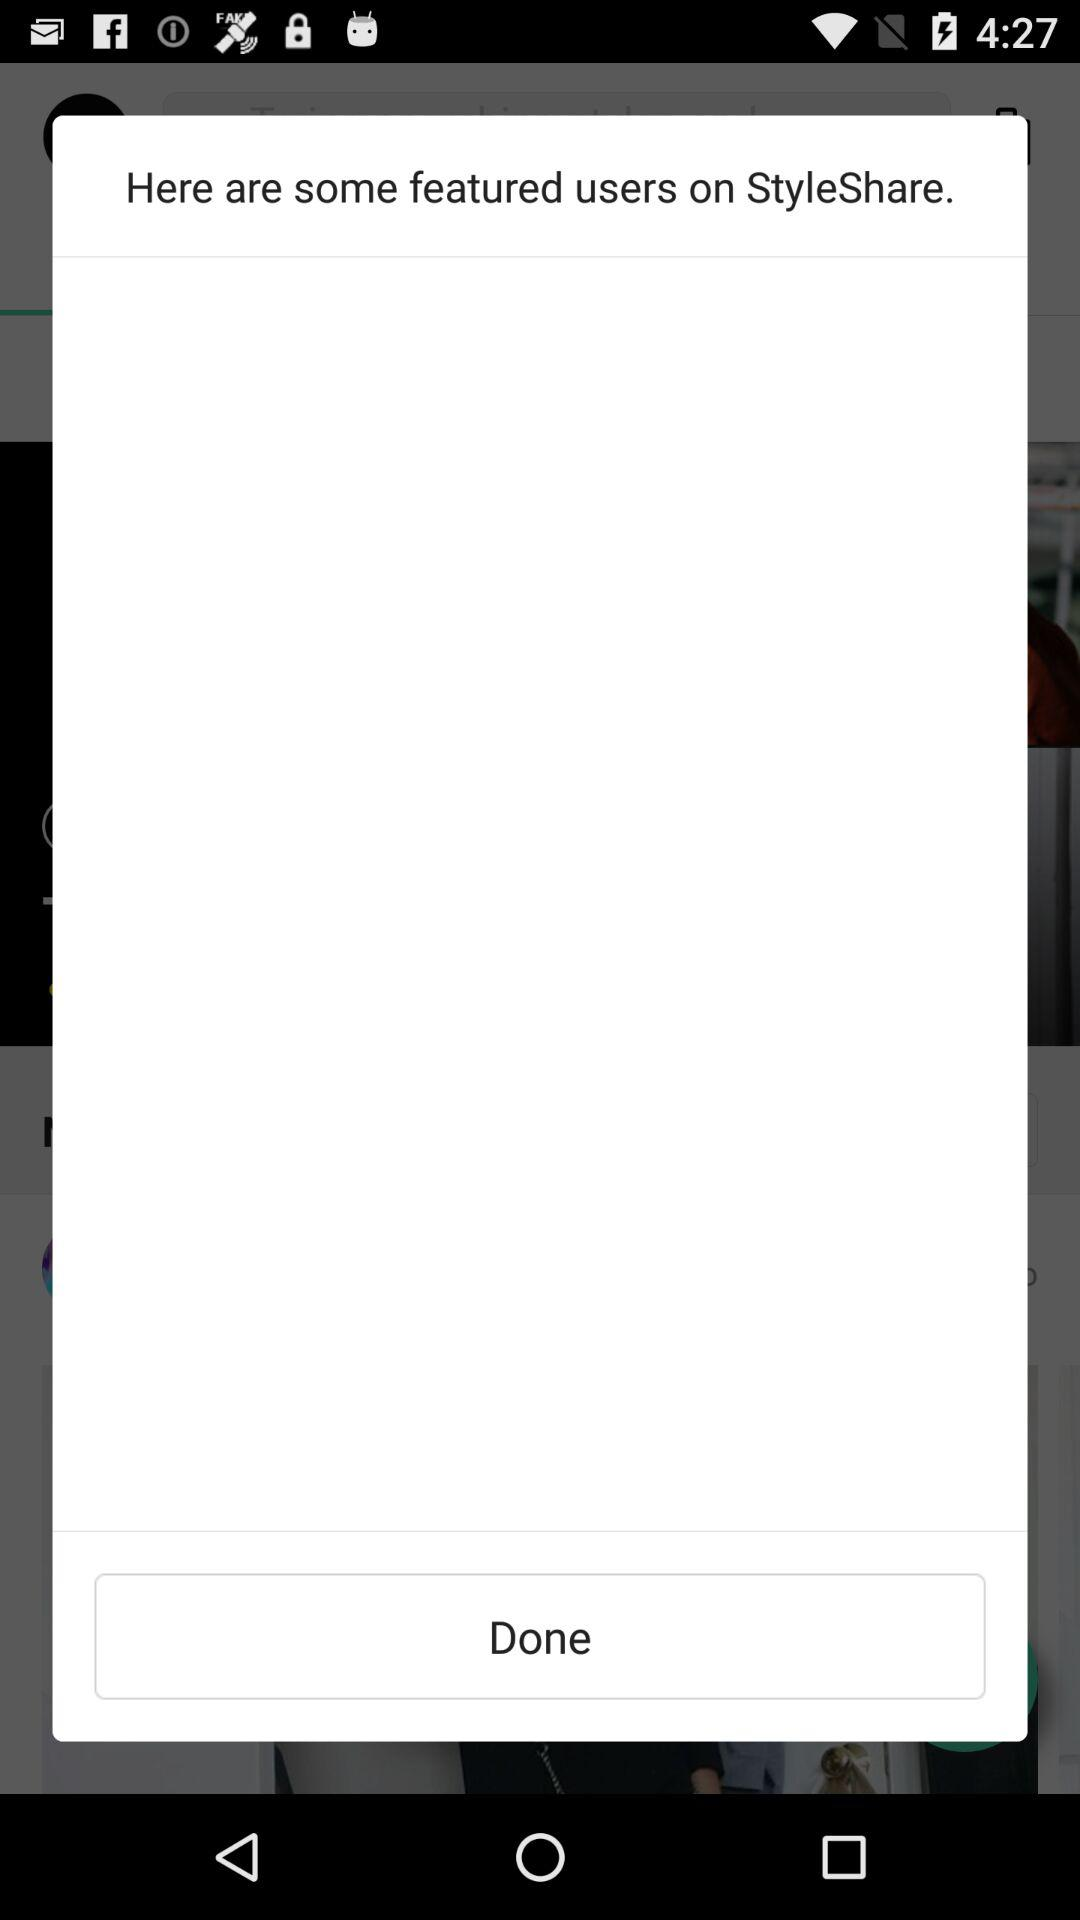What is the name of the application? The name of the application is "StyleShare". 